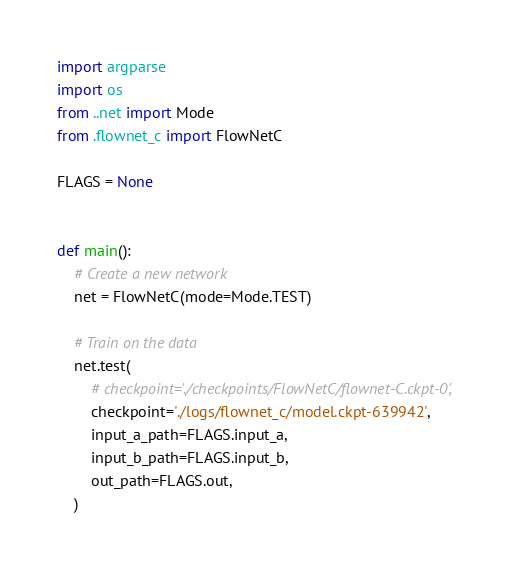Convert code to text. <code><loc_0><loc_0><loc_500><loc_500><_Python_>import argparse
import os
from ..net import Mode
from .flownet_c import FlowNetC

FLAGS = None


def main():
    # Create a new network
    net = FlowNetC(mode=Mode.TEST)

    # Train on the data
    net.test(
        # checkpoint='./checkpoints/FlowNetC/flownet-C.ckpt-0',
        checkpoint='./logs/flownet_c/model.ckpt-639942',
        input_a_path=FLAGS.input_a,
        input_b_path=FLAGS.input_b,
        out_path=FLAGS.out,
    )

</code> 